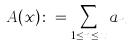<formula> <loc_0><loc_0><loc_500><loc_500>A ( x ) \colon = \sum _ { 1 \leq n \leq x } a _ { n }</formula> 